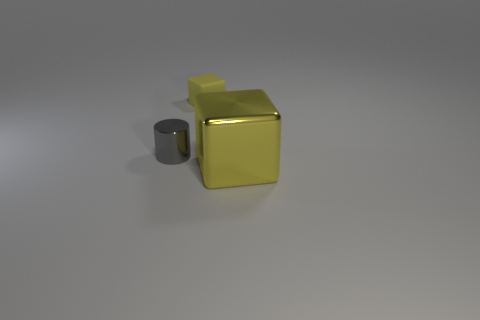Is there any other thing that is the same material as the small cylinder?
Your answer should be compact. Yes. What is the shape of the big shiny thing that is the same color as the rubber object?
Your answer should be compact. Cube. What is the small cube made of?
Provide a succinct answer. Rubber. Is the material of the gray object the same as the big yellow object?
Make the answer very short. Yes. What number of matte things are large red things or large blocks?
Provide a short and direct response. 0. There is a tiny thing that is on the right side of the gray object; what is its shape?
Give a very brief answer. Cube. There is a cylinder that is made of the same material as the large yellow thing; what is its size?
Your answer should be very brief. Small. There is a object that is both behind the metallic cube and right of the tiny gray object; what shape is it?
Ensure brevity in your answer.  Cube. There is a cube behind the metal cube; does it have the same color as the metallic cube?
Keep it short and to the point. Yes. There is a tiny thing that is right of the tiny gray metal object; does it have the same shape as the metal object that is in front of the gray cylinder?
Give a very brief answer. Yes. 